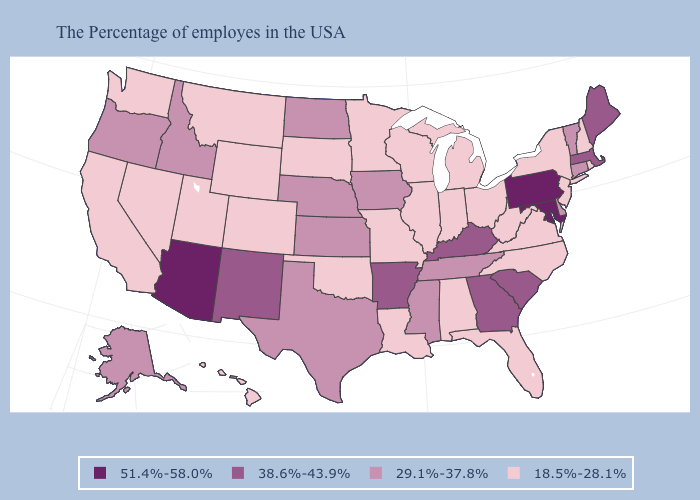Name the states that have a value in the range 18.5%-28.1%?
Quick response, please. Rhode Island, New Hampshire, New York, New Jersey, Virginia, North Carolina, West Virginia, Ohio, Florida, Michigan, Indiana, Alabama, Wisconsin, Illinois, Louisiana, Missouri, Minnesota, Oklahoma, South Dakota, Wyoming, Colorado, Utah, Montana, Nevada, California, Washington, Hawaii. What is the value of South Carolina?
Concise answer only. 38.6%-43.9%. Which states hav the highest value in the West?
Concise answer only. Arizona. What is the value of North Carolina?
Quick response, please. 18.5%-28.1%. What is the value of Texas?
Answer briefly. 29.1%-37.8%. Name the states that have a value in the range 38.6%-43.9%?
Concise answer only. Maine, Massachusetts, South Carolina, Georgia, Kentucky, Arkansas, New Mexico. How many symbols are there in the legend?
Short answer required. 4. What is the value of Missouri?
Concise answer only. 18.5%-28.1%. Name the states that have a value in the range 38.6%-43.9%?
Answer briefly. Maine, Massachusetts, South Carolina, Georgia, Kentucky, Arkansas, New Mexico. What is the lowest value in the USA?
Quick response, please. 18.5%-28.1%. What is the value of Maryland?
Keep it brief. 51.4%-58.0%. Which states have the lowest value in the USA?
Quick response, please. Rhode Island, New Hampshire, New York, New Jersey, Virginia, North Carolina, West Virginia, Ohio, Florida, Michigan, Indiana, Alabama, Wisconsin, Illinois, Louisiana, Missouri, Minnesota, Oklahoma, South Dakota, Wyoming, Colorado, Utah, Montana, Nevada, California, Washington, Hawaii. Does North Dakota have the highest value in the USA?
Be succinct. No. 